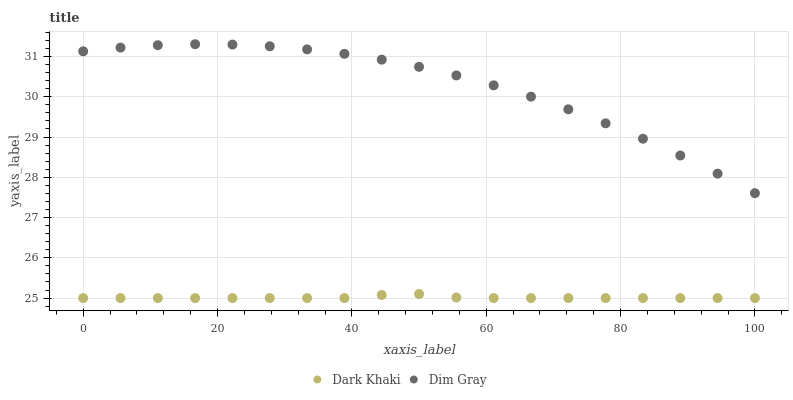Does Dark Khaki have the minimum area under the curve?
Answer yes or no. Yes. Does Dim Gray have the maximum area under the curve?
Answer yes or no. Yes. Does Dim Gray have the minimum area under the curve?
Answer yes or no. No. Is Dark Khaki the smoothest?
Answer yes or no. Yes. Is Dim Gray the roughest?
Answer yes or no. Yes. Is Dim Gray the smoothest?
Answer yes or no. No. Does Dark Khaki have the lowest value?
Answer yes or no. Yes. Does Dim Gray have the lowest value?
Answer yes or no. No. Does Dim Gray have the highest value?
Answer yes or no. Yes. Is Dark Khaki less than Dim Gray?
Answer yes or no. Yes. Is Dim Gray greater than Dark Khaki?
Answer yes or no. Yes. Does Dark Khaki intersect Dim Gray?
Answer yes or no. No. 